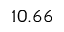Convert formula to latex. <formula><loc_0><loc_0><loc_500><loc_500>1 0 . 6 6</formula> 